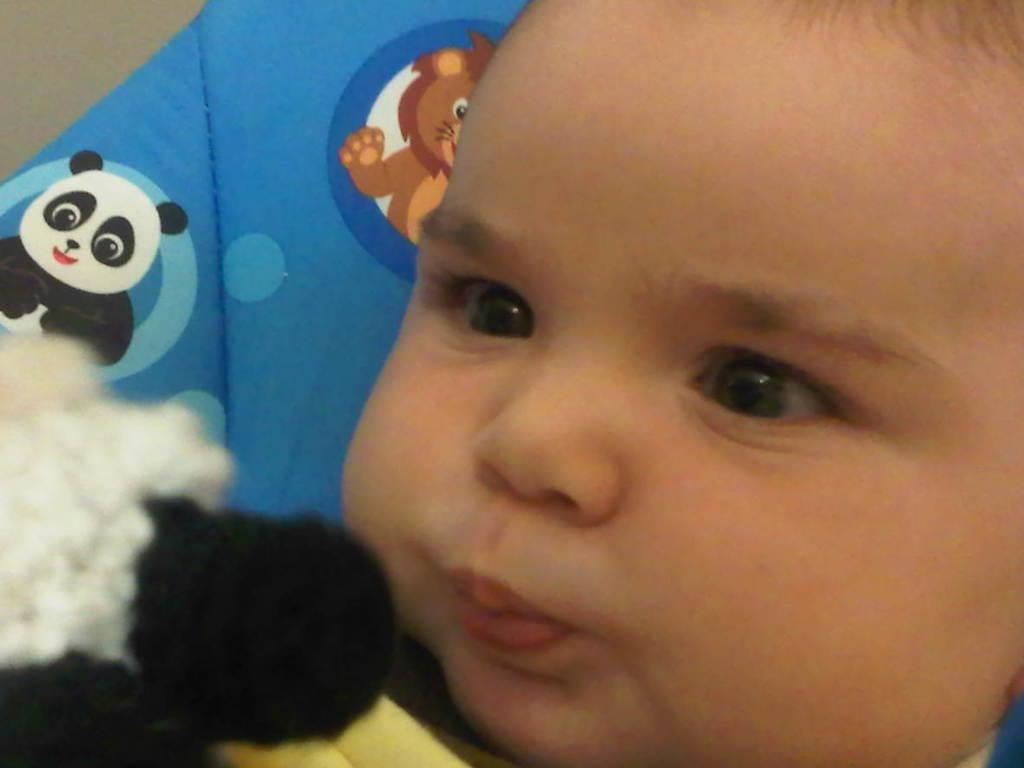What is the main subject of the image? There is a baby in the image. What is the baby sitting or lying on? The baby is on a blue surface. What type of images are present on the surface? There are animal cartoon images on the surface. What type of lamp is present in the image? There is no lamp present in the image. How does the baby express anger in the image? The baby does not express anger in the image, as there is no indication of emotion. 